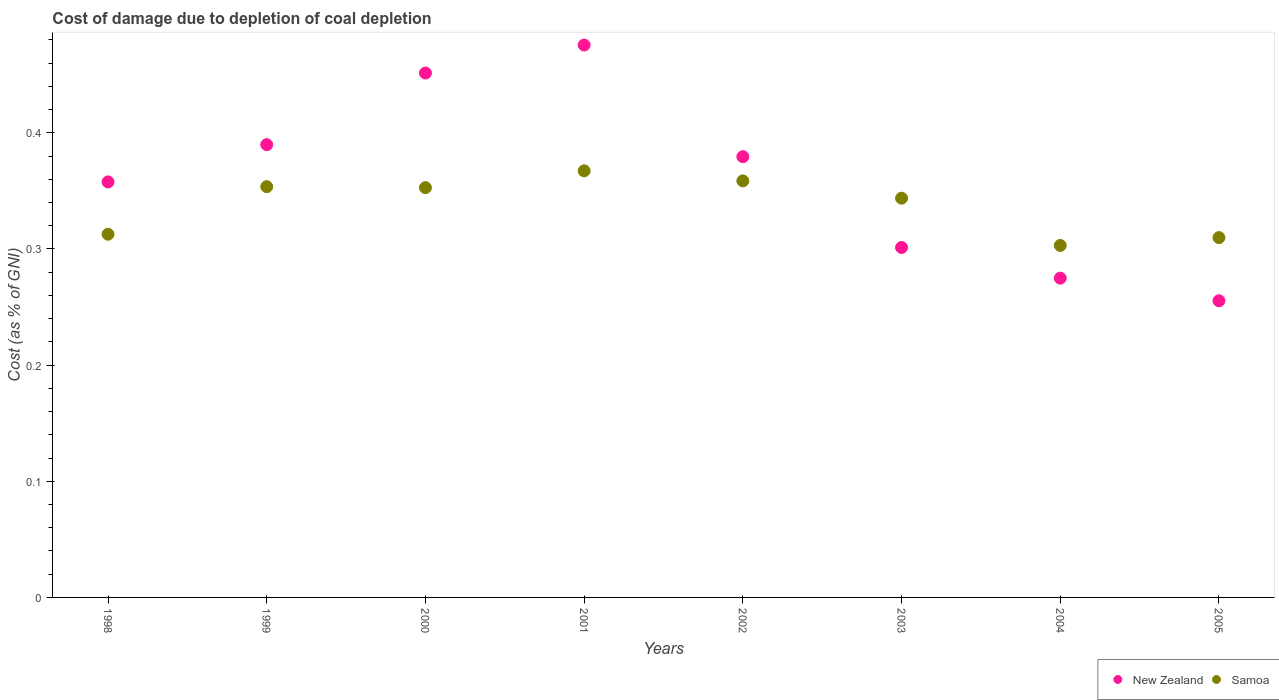Is the number of dotlines equal to the number of legend labels?
Your response must be concise. Yes. What is the cost of damage caused due to coal depletion in Samoa in 1999?
Offer a very short reply. 0.35. Across all years, what is the maximum cost of damage caused due to coal depletion in New Zealand?
Your response must be concise. 0.48. Across all years, what is the minimum cost of damage caused due to coal depletion in New Zealand?
Keep it short and to the point. 0.26. In which year was the cost of damage caused due to coal depletion in Samoa maximum?
Give a very brief answer. 2001. In which year was the cost of damage caused due to coal depletion in New Zealand minimum?
Your response must be concise. 2005. What is the total cost of damage caused due to coal depletion in New Zealand in the graph?
Provide a succinct answer. 2.89. What is the difference between the cost of damage caused due to coal depletion in Samoa in 1999 and that in 2005?
Keep it short and to the point. 0.04. What is the difference between the cost of damage caused due to coal depletion in New Zealand in 2002 and the cost of damage caused due to coal depletion in Samoa in 2000?
Your answer should be very brief. 0.03. What is the average cost of damage caused due to coal depletion in Samoa per year?
Offer a very short reply. 0.34. In the year 2002, what is the difference between the cost of damage caused due to coal depletion in New Zealand and cost of damage caused due to coal depletion in Samoa?
Provide a succinct answer. 0.02. In how many years, is the cost of damage caused due to coal depletion in New Zealand greater than 0.28 %?
Give a very brief answer. 6. What is the ratio of the cost of damage caused due to coal depletion in New Zealand in 1998 to that in 2000?
Your response must be concise. 0.79. Is the cost of damage caused due to coal depletion in Samoa in 2003 less than that in 2005?
Offer a very short reply. No. Is the difference between the cost of damage caused due to coal depletion in New Zealand in 2004 and 2005 greater than the difference between the cost of damage caused due to coal depletion in Samoa in 2004 and 2005?
Make the answer very short. Yes. What is the difference between the highest and the second highest cost of damage caused due to coal depletion in Samoa?
Your answer should be compact. 0.01. What is the difference between the highest and the lowest cost of damage caused due to coal depletion in Samoa?
Provide a succinct answer. 0.06. In how many years, is the cost of damage caused due to coal depletion in New Zealand greater than the average cost of damage caused due to coal depletion in New Zealand taken over all years?
Provide a succinct answer. 4. Is the sum of the cost of damage caused due to coal depletion in New Zealand in 1998 and 2001 greater than the maximum cost of damage caused due to coal depletion in Samoa across all years?
Your response must be concise. Yes. How many years are there in the graph?
Offer a very short reply. 8. Does the graph contain grids?
Ensure brevity in your answer.  No. How many legend labels are there?
Provide a succinct answer. 2. How are the legend labels stacked?
Your response must be concise. Horizontal. What is the title of the graph?
Make the answer very short. Cost of damage due to depletion of coal depletion. Does "Seychelles" appear as one of the legend labels in the graph?
Offer a very short reply. No. What is the label or title of the Y-axis?
Make the answer very short. Cost (as % of GNI). What is the Cost (as % of GNI) of New Zealand in 1998?
Provide a short and direct response. 0.36. What is the Cost (as % of GNI) of Samoa in 1998?
Your answer should be very brief. 0.31. What is the Cost (as % of GNI) in New Zealand in 1999?
Ensure brevity in your answer.  0.39. What is the Cost (as % of GNI) of Samoa in 1999?
Give a very brief answer. 0.35. What is the Cost (as % of GNI) in New Zealand in 2000?
Your answer should be very brief. 0.45. What is the Cost (as % of GNI) of Samoa in 2000?
Give a very brief answer. 0.35. What is the Cost (as % of GNI) of New Zealand in 2001?
Your answer should be compact. 0.48. What is the Cost (as % of GNI) of Samoa in 2001?
Provide a short and direct response. 0.37. What is the Cost (as % of GNI) of New Zealand in 2002?
Offer a very short reply. 0.38. What is the Cost (as % of GNI) in Samoa in 2002?
Your response must be concise. 0.36. What is the Cost (as % of GNI) in New Zealand in 2003?
Provide a short and direct response. 0.3. What is the Cost (as % of GNI) in Samoa in 2003?
Make the answer very short. 0.34. What is the Cost (as % of GNI) in New Zealand in 2004?
Your answer should be very brief. 0.27. What is the Cost (as % of GNI) of Samoa in 2004?
Offer a terse response. 0.3. What is the Cost (as % of GNI) of New Zealand in 2005?
Provide a short and direct response. 0.26. What is the Cost (as % of GNI) in Samoa in 2005?
Your answer should be compact. 0.31. Across all years, what is the maximum Cost (as % of GNI) of New Zealand?
Give a very brief answer. 0.48. Across all years, what is the maximum Cost (as % of GNI) in Samoa?
Your answer should be compact. 0.37. Across all years, what is the minimum Cost (as % of GNI) of New Zealand?
Ensure brevity in your answer.  0.26. Across all years, what is the minimum Cost (as % of GNI) of Samoa?
Your answer should be very brief. 0.3. What is the total Cost (as % of GNI) of New Zealand in the graph?
Keep it short and to the point. 2.89. What is the total Cost (as % of GNI) in Samoa in the graph?
Ensure brevity in your answer.  2.7. What is the difference between the Cost (as % of GNI) of New Zealand in 1998 and that in 1999?
Your answer should be compact. -0.03. What is the difference between the Cost (as % of GNI) of Samoa in 1998 and that in 1999?
Give a very brief answer. -0.04. What is the difference between the Cost (as % of GNI) of New Zealand in 1998 and that in 2000?
Give a very brief answer. -0.09. What is the difference between the Cost (as % of GNI) of Samoa in 1998 and that in 2000?
Ensure brevity in your answer.  -0.04. What is the difference between the Cost (as % of GNI) in New Zealand in 1998 and that in 2001?
Make the answer very short. -0.12. What is the difference between the Cost (as % of GNI) in Samoa in 1998 and that in 2001?
Keep it short and to the point. -0.05. What is the difference between the Cost (as % of GNI) in New Zealand in 1998 and that in 2002?
Ensure brevity in your answer.  -0.02. What is the difference between the Cost (as % of GNI) in Samoa in 1998 and that in 2002?
Your answer should be very brief. -0.05. What is the difference between the Cost (as % of GNI) of New Zealand in 1998 and that in 2003?
Make the answer very short. 0.06. What is the difference between the Cost (as % of GNI) in Samoa in 1998 and that in 2003?
Offer a terse response. -0.03. What is the difference between the Cost (as % of GNI) in New Zealand in 1998 and that in 2004?
Offer a very short reply. 0.08. What is the difference between the Cost (as % of GNI) of Samoa in 1998 and that in 2004?
Offer a very short reply. 0.01. What is the difference between the Cost (as % of GNI) of New Zealand in 1998 and that in 2005?
Provide a short and direct response. 0.1. What is the difference between the Cost (as % of GNI) in Samoa in 1998 and that in 2005?
Offer a very short reply. 0. What is the difference between the Cost (as % of GNI) of New Zealand in 1999 and that in 2000?
Keep it short and to the point. -0.06. What is the difference between the Cost (as % of GNI) in Samoa in 1999 and that in 2000?
Provide a succinct answer. 0. What is the difference between the Cost (as % of GNI) of New Zealand in 1999 and that in 2001?
Offer a very short reply. -0.09. What is the difference between the Cost (as % of GNI) of Samoa in 1999 and that in 2001?
Your answer should be compact. -0.01. What is the difference between the Cost (as % of GNI) of New Zealand in 1999 and that in 2002?
Your response must be concise. 0.01. What is the difference between the Cost (as % of GNI) in Samoa in 1999 and that in 2002?
Your answer should be compact. -0.01. What is the difference between the Cost (as % of GNI) in New Zealand in 1999 and that in 2003?
Your response must be concise. 0.09. What is the difference between the Cost (as % of GNI) of Samoa in 1999 and that in 2003?
Provide a short and direct response. 0.01. What is the difference between the Cost (as % of GNI) of New Zealand in 1999 and that in 2004?
Give a very brief answer. 0.11. What is the difference between the Cost (as % of GNI) in Samoa in 1999 and that in 2004?
Your answer should be very brief. 0.05. What is the difference between the Cost (as % of GNI) in New Zealand in 1999 and that in 2005?
Your answer should be compact. 0.13. What is the difference between the Cost (as % of GNI) of Samoa in 1999 and that in 2005?
Provide a short and direct response. 0.04. What is the difference between the Cost (as % of GNI) of New Zealand in 2000 and that in 2001?
Make the answer very short. -0.02. What is the difference between the Cost (as % of GNI) of Samoa in 2000 and that in 2001?
Your answer should be very brief. -0.01. What is the difference between the Cost (as % of GNI) in New Zealand in 2000 and that in 2002?
Provide a succinct answer. 0.07. What is the difference between the Cost (as % of GNI) of Samoa in 2000 and that in 2002?
Offer a very short reply. -0.01. What is the difference between the Cost (as % of GNI) of New Zealand in 2000 and that in 2003?
Your answer should be very brief. 0.15. What is the difference between the Cost (as % of GNI) of Samoa in 2000 and that in 2003?
Your response must be concise. 0.01. What is the difference between the Cost (as % of GNI) of New Zealand in 2000 and that in 2004?
Ensure brevity in your answer.  0.18. What is the difference between the Cost (as % of GNI) of Samoa in 2000 and that in 2004?
Make the answer very short. 0.05. What is the difference between the Cost (as % of GNI) in New Zealand in 2000 and that in 2005?
Offer a terse response. 0.2. What is the difference between the Cost (as % of GNI) in Samoa in 2000 and that in 2005?
Your answer should be very brief. 0.04. What is the difference between the Cost (as % of GNI) in New Zealand in 2001 and that in 2002?
Your answer should be compact. 0.1. What is the difference between the Cost (as % of GNI) in Samoa in 2001 and that in 2002?
Provide a succinct answer. 0.01. What is the difference between the Cost (as % of GNI) in New Zealand in 2001 and that in 2003?
Make the answer very short. 0.17. What is the difference between the Cost (as % of GNI) in Samoa in 2001 and that in 2003?
Keep it short and to the point. 0.02. What is the difference between the Cost (as % of GNI) of New Zealand in 2001 and that in 2004?
Ensure brevity in your answer.  0.2. What is the difference between the Cost (as % of GNI) of Samoa in 2001 and that in 2004?
Make the answer very short. 0.06. What is the difference between the Cost (as % of GNI) in New Zealand in 2001 and that in 2005?
Provide a succinct answer. 0.22. What is the difference between the Cost (as % of GNI) of Samoa in 2001 and that in 2005?
Your response must be concise. 0.06. What is the difference between the Cost (as % of GNI) in New Zealand in 2002 and that in 2003?
Make the answer very short. 0.08. What is the difference between the Cost (as % of GNI) of Samoa in 2002 and that in 2003?
Provide a succinct answer. 0.01. What is the difference between the Cost (as % of GNI) of New Zealand in 2002 and that in 2004?
Make the answer very short. 0.1. What is the difference between the Cost (as % of GNI) in Samoa in 2002 and that in 2004?
Your answer should be compact. 0.06. What is the difference between the Cost (as % of GNI) in New Zealand in 2002 and that in 2005?
Provide a short and direct response. 0.12. What is the difference between the Cost (as % of GNI) in Samoa in 2002 and that in 2005?
Your answer should be compact. 0.05. What is the difference between the Cost (as % of GNI) of New Zealand in 2003 and that in 2004?
Ensure brevity in your answer.  0.03. What is the difference between the Cost (as % of GNI) of Samoa in 2003 and that in 2004?
Provide a succinct answer. 0.04. What is the difference between the Cost (as % of GNI) of New Zealand in 2003 and that in 2005?
Make the answer very short. 0.05. What is the difference between the Cost (as % of GNI) of Samoa in 2003 and that in 2005?
Ensure brevity in your answer.  0.03. What is the difference between the Cost (as % of GNI) of New Zealand in 2004 and that in 2005?
Ensure brevity in your answer.  0.02. What is the difference between the Cost (as % of GNI) of Samoa in 2004 and that in 2005?
Provide a short and direct response. -0.01. What is the difference between the Cost (as % of GNI) in New Zealand in 1998 and the Cost (as % of GNI) in Samoa in 1999?
Ensure brevity in your answer.  0. What is the difference between the Cost (as % of GNI) of New Zealand in 1998 and the Cost (as % of GNI) of Samoa in 2000?
Give a very brief answer. 0. What is the difference between the Cost (as % of GNI) of New Zealand in 1998 and the Cost (as % of GNI) of Samoa in 2001?
Keep it short and to the point. -0.01. What is the difference between the Cost (as % of GNI) in New Zealand in 1998 and the Cost (as % of GNI) in Samoa in 2002?
Provide a succinct answer. -0. What is the difference between the Cost (as % of GNI) of New Zealand in 1998 and the Cost (as % of GNI) of Samoa in 2003?
Give a very brief answer. 0.01. What is the difference between the Cost (as % of GNI) of New Zealand in 1998 and the Cost (as % of GNI) of Samoa in 2004?
Keep it short and to the point. 0.05. What is the difference between the Cost (as % of GNI) of New Zealand in 1998 and the Cost (as % of GNI) of Samoa in 2005?
Keep it short and to the point. 0.05. What is the difference between the Cost (as % of GNI) of New Zealand in 1999 and the Cost (as % of GNI) of Samoa in 2000?
Make the answer very short. 0.04. What is the difference between the Cost (as % of GNI) in New Zealand in 1999 and the Cost (as % of GNI) in Samoa in 2001?
Offer a very short reply. 0.02. What is the difference between the Cost (as % of GNI) in New Zealand in 1999 and the Cost (as % of GNI) in Samoa in 2002?
Your response must be concise. 0.03. What is the difference between the Cost (as % of GNI) in New Zealand in 1999 and the Cost (as % of GNI) in Samoa in 2003?
Your answer should be very brief. 0.05. What is the difference between the Cost (as % of GNI) in New Zealand in 1999 and the Cost (as % of GNI) in Samoa in 2004?
Your answer should be compact. 0.09. What is the difference between the Cost (as % of GNI) in New Zealand in 2000 and the Cost (as % of GNI) in Samoa in 2001?
Give a very brief answer. 0.08. What is the difference between the Cost (as % of GNI) in New Zealand in 2000 and the Cost (as % of GNI) in Samoa in 2002?
Keep it short and to the point. 0.09. What is the difference between the Cost (as % of GNI) in New Zealand in 2000 and the Cost (as % of GNI) in Samoa in 2003?
Keep it short and to the point. 0.11. What is the difference between the Cost (as % of GNI) in New Zealand in 2000 and the Cost (as % of GNI) in Samoa in 2004?
Your response must be concise. 0.15. What is the difference between the Cost (as % of GNI) in New Zealand in 2000 and the Cost (as % of GNI) in Samoa in 2005?
Provide a short and direct response. 0.14. What is the difference between the Cost (as % of GNI) of New Zealand in 2001 and the Cost (as % of GNI) of Samoa in 2002?
Keep it short and to the point. 0.12. What is the difference between the Cost (as % of GNI) of New Zealand in 2001 and the Cost (as % of GNI) of Samoa in 2003?
Keep it short and to the point. 0.13. What is the difference between the Cost (as % of GNI) in New Zealand in 2001 and the Cost (as % of GNI) in Samoa in 2004?
Keep it short and to the point. 0.17. What is the difference between the Cost (as % of GNI) of New Zealand in 2001 and the Cost (as % of GNI) of Samoa in 2005?
Provide a succinct answer. 0.17. What is the difference between the Cost (as % of GNI) in New Zealand in 2002 and the Cost (as % of GNI) in Samoa in 2003?
Give a very brief answer. 0.04. What is the difference between the Cost (as % of GNI) in New Zealand in 2002 and the Cost (as % of GNI) in Samoa in 2004?
Your response must be concise. 0.08. What is the difference between the Cost (as % of GNI) of New Zealand in 2002 and the Cost (as % of GNI) of Samoa in 2005?
Provide a succinct answer. 0.07. What is the difference between the Cost (as % of GNI) in New Zealand in 2003 and the Cost (as % of GNI) in Samoa in 2004?
Provide a succinct answer. -0. What is the difference between the Cost (as % of GNI) of New Zealand in 2003 and the Cost (as % of GNI) of Samoa in 2005?
Your answer should be very brief. -0.01. What is the difference between the Cost (as % of GNI) in New Zealand in 2004 and the Cost (as % of GNI) in Samoa in 2005?
Give a very brief answer. -0.03. What is the average Cost (as % of GNI) of New Zealand per year?
Provide a succinct answer. 0.36. What is the average Cost (as % of GNI) in Samoa per year?
Offer a terse response. 0.34. In the year 1998, what is the difference between the Cost (as % of GNI) of New Zealand and Cost (as % of GNI) of Samoa?
Make the answer very short. 0.04. In the year 1999, what is the difference between the Cost (as % of GNI) in New Zealand and Cost (as % of GNI) in Samoa?
Provide a succinct answer. 0.04. In the year 2000, what is the difference between the Cost (as % of GNI) of New Zealand and Cost (as % of GNI) of Samoa?
Your answer should be very brief. 0.1. In the year 2001, what is the difference between the Cost (as % of GNI) of New Zealand and Cost (as % of GNI) of Samoa?
Provide a succinct answer. 0.11. In the year 2002, what is the difference between the Cost (as % of GNI) in New Zealand and Cost (as % of GNI) in Samoa?
Offer a terse response. 0.02. In the year 2003, what is the difference between the Cost (as % of GNI) of New Zealand and Cost (as % of GNI) of Samoa?
Your answer should be very brief. -0.04. In the year 2004, what is the difference between the Cost (as % of GNI) of New Zealand and Cost (as % of GNI) of Samoa?
Give a very brief answer. -0.03. In the year 2005, what is the difference between the Cost (as % of GNI) of New Zealand and Cost (as % of GNI) of Samoa?
Keep it short and to the point. -0.05. What is the ratio of the Cost (as % of GNI) in New Zealand in 1998 to that in 1999?
Your answer should be very brief. 0.92. What is the ratio of the Cost (as % of GNI) in Samoa in 1998 to that in 1999?
Your answer should be compact. 0.88. What is the ratio of the Cost (as % of GNI) in New Zealand in 1998 to that in 2000?
Make the answer very short. 0.79. What is the ratio of the Cost (as % of GNI) of Samoa in 1998 to that in 2000?
Provide a short and direct response. 0.89. What is the ratio of the Cost (as % of GNI) in New Zealand in 1998 to that in 2001?
Your response must be concise. 0.75. What is the ratio of the Cost (as % of GNI) of Samoa in 1998 to that in 2001?
Make the answer very short. 0.85. What is the ratio of the Cost (as % of GNI) in New Zealand in 1998 to that in 2002?
Offer a terse response. 0.94. What is the ratio of the Cost (as % of GNI) in Samoa in 1998 to that in 2002?
Provide a short and direct response. 0.87. What is the ratio of the Cost (as % of GNI) of New Zealand in 1998 to that in 2003?
Make the answer very short. 1.19. What is the ratio of the Cost (as % of GNI) in Samoa in 1998 to that in 2003?
Your answer should be very brief. 0.91. What is the ratio of the Cost (as % of GNI) in New Zealand in 1998 to that in 2004?
Provide a short and direct response. 1.3. What is the ratio of the Cost (as % of GNI) in Samoa in 1998 to that in 2004?
Offer a very short reply. 1.03. What is the ratio of the Cost (as % of GNI) in New Zealand in 1998 to that in 2005?
Your answer should be very brief. 1.4. What is the ratio of the Cost (as % of GNI) in Samoa in 1998 to that in 2005?
Offer a terse response. 1.01. What is the ratio of the Cost (as % of GNI) of New Zealand in 1999 to that in 2000?
Your answer should be very brief. 0.86. What is the ratio of the Cost (as % of GNI) of New Zealand in 1999 to that in 2001?
Provide a short and direct response. 0.82. What is the ratio of the Cost (as % of GNI) in Samoa in 1999 to that in 2001?
Your answer should be very brief. 0.96. What is the ratio of the Cost (as % of GNI) of New Zealand in 1999 to that in 2002?
Give a very brief answer. 1.03. What is the ratio of the Cost (as % of GNI) in Samoa in 1999 to that in 2002?
Your answer should be compact. 0.99. What is the ratio of the Cost (as % of GNI) in New Zealand in 1999 to that in 2003?
Your response must be concise. 1.29. What is the ratio of the Cost (as % of GNI) of Samoa in 1999 to that in 2003?
Ensure brevity in your answer.  1.03. What is the ratio of the Cost (as % of GNI) in New Zealand in 1999 to that in 2004?
Ensure brevity in your answer.  1.42. What is the ratio of the Cost (as % of GNI) of Samoa in 1999 to that in 2004?
Offer a terse response. 1.17. What is the ratio of the Cost (as % of GNI) of New Zealand in 1999 to that in 2005?
Offer a terse response. 1.53. What is the ratio of the Cost (as % of GNI) in Samoa in 1999 to that in 2005?
Offer a terse response. 1.14. What is the ratio of the Cost (as % of GNI) in New Zealand in 2000 to that in 2001?
Provide a succinct answer. 0.95. What is the ratio of the Cost (as % of GNI) in Samoa in 2000 to that in 2001?
Offer a terse response. 0.96. What is the ratio of the Cost (as % of GNI) in New Zealand in 2000 to that in 2002?
Your answer should be compact. 1.19. What is the ratio of the Cost (as % of GNI) of Samoa in 2000 to that in 2002?
Make the answer very short. 0.98. What is the ratio of the Cost (as % of GNI) in New Zealand in 2000 to that in 2003?
Offer a very short reply. 1.5. What is the ratio of the Cost (as % of GNI) in Samoa in 2000 to that in 2003?
Offer a very short reply. 1.03. What is the ratio of the Cost (as % of GNI) in New Zealand in 2000 to that in 2004?
Your response must be concise. 1.64. What is the ratio of the Cost (as % of GNI) of Samoa in 2000 to that in 2004?
Offer a very short reply. 1.16. What is the ratio of the Cost (as % of GNI) in New Zealand in 2000 to that in 2005?
Keep it short and to the point. 1.77. What is the ratio of the Cost (as % of GNI) of Samoa in 2000 to that in 2005?
Give a very brief answer. 1.14. What is the ratio of the Cost (as % of GNI) in New Zealand in 2001 to that in 2002?
Your answer should be very brief. 1.25. What is the ratio of the Cost (as % of GNI) of Samoa in 2001 to that in 2002?
Your response must be concise. 1.02. What is the ratio of the Cost (as % of GNI) in New Zealand in 2001 to that in 2003?
Provide a short and direct response. 1.58. What is the ratio of the Cost (as % of GNI) of Samoa in 2001 to that in 2003?
Ensure brevity in your answer.  1.07. What is the ratio of the Cost (as % of GNI) in New Zealand in 2001 to that in 2004?
Provide a succinct answer. 1.73. What is the ratio of the Cost (as % of GNI) in Samoa in 2001 to that in 2004?
Your answer should be compact. 1.21. What is the ratio of the Cost (as % of GNI) of New Zealand in 2001 to that in 2005?
Offer a very short reply. 1.86. What is the ratio of the Cost (as % of GNI) of Samoa in 2001 to that in 2005?
Provide a short and direct response. 1.19. What is the ratio of the Cost (as % of GNI) in New Zealand in 2002 to that in 2003?
Give a very brief answer. 1.26. What is the ratio of the Cost (as % of GNI) of Samoa in 2002 to that in 2003?
Provide a short and direct response. 1.04. What is the ratio of the Cost (as % of GNI) of New Zealand in 2002 to that in 2004?
Your answer should be very brief. 1.38. What is the ratio of the Cost (as % of GNI) of Samoa in 2002 to that in 2004?
Make the answer very short. 1.18. What is the ratio of the Cost (as % of GNI) in New Zealand in 2002 to that in 2005?
Offer a very short reply. 1.49. What is the ratio of the Cost (as % of GNI) in Samoa in 2002 to that in 2005?
Your response must be concise. 1.16. What is the ratio of the Cost (as % of GNI) of New Zealand in 2003 to that in 2004?
Provide a succinct answer. 1.1. What is the ratio of the Cost (as % of GNI) of Samoa in 2003 to that in 2004?
Make the answer very short. 1.13. What is the ratio of the Cost (as % of GNI) in New Zealand in 2003 to that in 2005?
Offer a very short reply. 1.18. What is the ratio of the Cost (as % of GNI) of Samoa in 2003 to that in 2005?
Ensure brevity in your answer.  1.11. What is the ratio of the Cost (as % of GNI) of New Zealand in 2004 to that in 2005?
Provide a short and direct response. 1.08. What is the ratio of the Cost (as % of GNI) in Samoa in 2004 to that in 2005?
Offer a terse response. 0.98. What is the difference between the highest and the second highest Cost (as % of GNI) of New Zealand?
Provide a succinct answer. 0.02. What is the difference between the highest and the second highest Cost (as % of GNI) of Samoa?
Offer a terse response. 0.01. What is the difference between the highest and the lowest Cost (as % of GNI) of New Zealand?
Provide a short and direct response. 0.22. What is the difference between the highest and the lowest Cost (as % of GNI) in Samoa?
Your response must be concise. 0.06. 